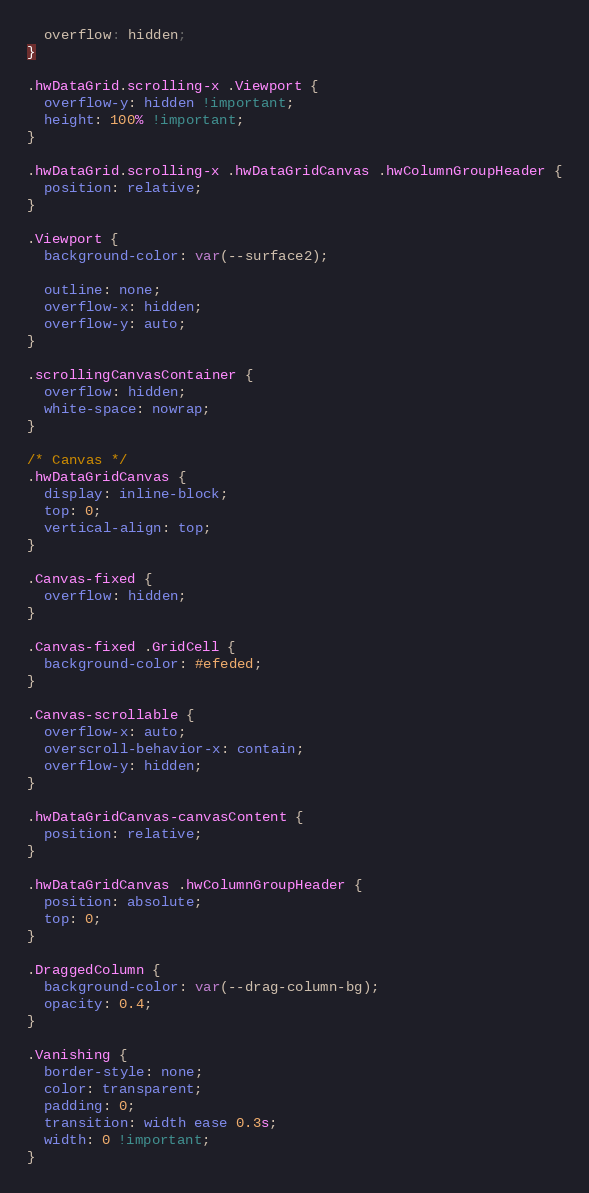Convert code to text. <code><loc_0><loc_0><loc_500><loc_500><_CSS_>  overflow: hidden;
}

.hwDataGrid.scrolling-x .Viewport {
  overflow-y: hidden !important;
  height: 100% !important;
}

.hwDataGrid.scrolling-x .hwDataGridCanvas .hwColumnGroupHeader {
  position: relative;
}

.Viewport {
  background-color: var(--surface2);

  outline: none;
  overflow-x: hidden;
  overflow-y: auto;
}

.scrollingCanvasContainer {
  overflow: hidden;
  white-space: nowrap;
}

/* Canvas */
.hwDataGridCanvas {
  display: inline-block;
  top: 0;
  vertical-align: top;
}

.Canvas-fixed {
  overflow: hidden;
}

.Canvas-fixed .GridCell {
  background-color: #efeded;
}

.Canvas-scrollable {
  overflow-x: auto;
  overscroll-behavior-x: contain;
  overflow-y: hidden;
}

.hwDataGridCanvas-canvasContent {
  position: relative;
}

.hwDataGridCanvas .hwColumnGroupHeader {
  position: absolute;
  top: 0;
}

.DraggedColumn {
  background-color: var(--drag-column-bg);
  opacity: 0.4;
}

.Vanishing {
  border-style: none;
  color: transparent;
  padding: 0;
  transition: width ease 0.3s;
  width: 0 !important;
}
</code> 